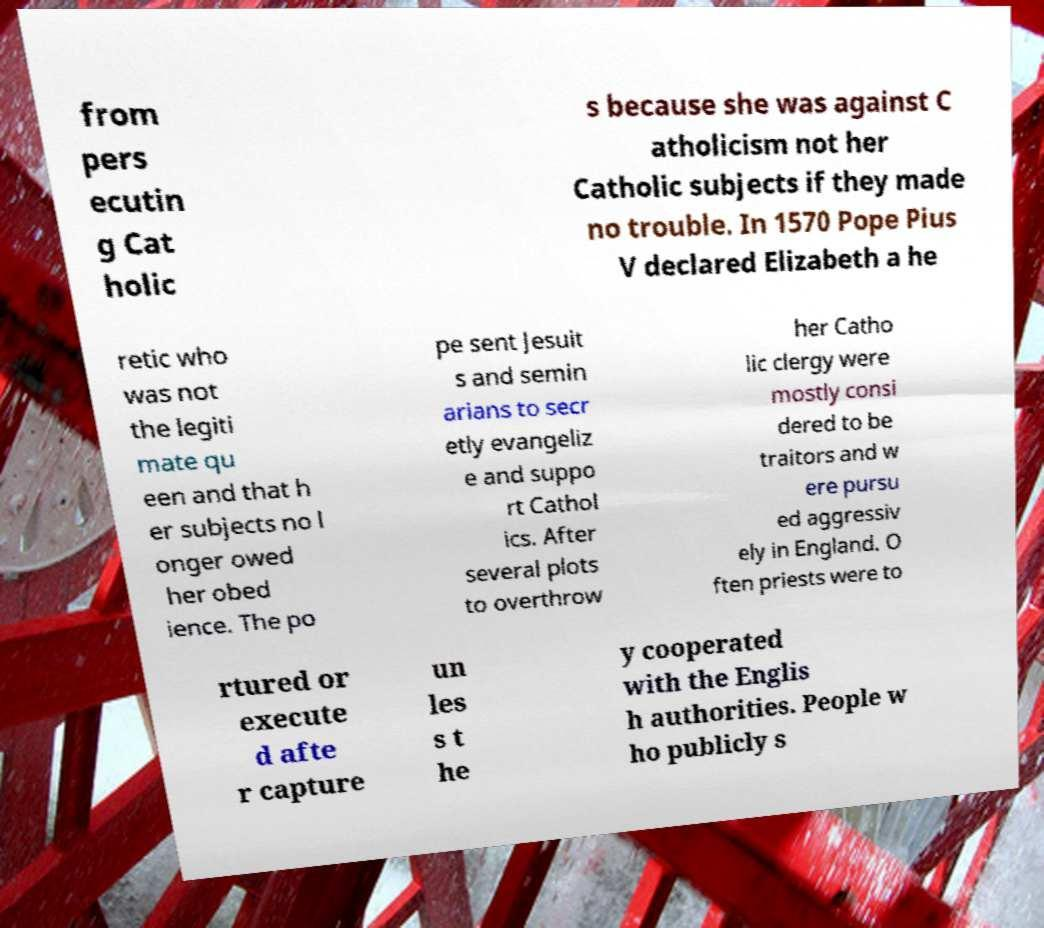I need the written content from this picture converted into text. Can you do that? from pers ecutin g Cat holic s because she was against C atholicism not her Catholic subjects if they made no trouble. In 1570 Pope Pius V declared Elizabeth a he retic who was not the legiti mate qu een and that h er subjects no l onger owed her obed ience. The po pe sent Jesuit s and semin arians to secr etly evangeliz e and suppo rt Cathol ics. After several plots to overthrow her Catho lic clergy were mostly consi dered to be traitors and w ere pursu ed aggressiv ely in England. O ften priests were to rtured or execute d afte r capture un les s t he y cooperated with the Englis h authorities. People w ho publicly s 